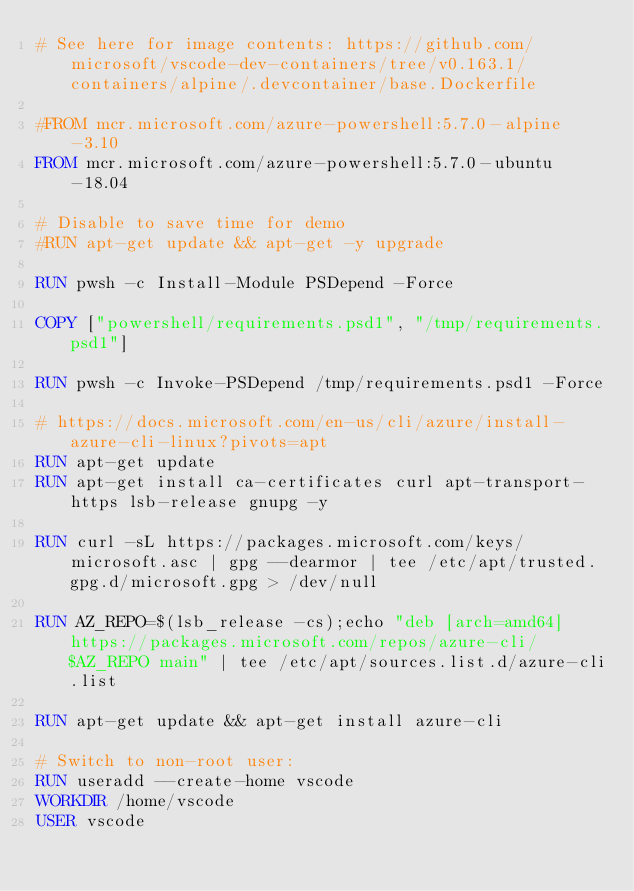<code> <loc_0><loc_0><loc_500><loc_500><_Dockerfile_># See here for image contents: https://github.com/microsoft/vscode-dev-containers/tree/v0.163.1/containers/alpine/.devcontainer/base.Dockerfile

#FROM mcr.microsoft.com/azure-powershell:5.7.0-alpine-3.10
FROM mcr.microsoft.com/azure-powershell:5.7.0-ubuntu-18.04

# Disable to save time for demo
#RUN apt-get update && apt-get -y upgrade

RUN pwsh -c Install-Module PSDepend -Force

COPY ["powershell/requirements.psd1", "/tmp/requirements.psd1"]

RUN pwsh -c Invoke-PSDepend /tmp/requirements.psd1 -Force

# https://docs.microsoft.com/en-us/cli/azure/install-azure-cli-linux?pivots=apt
RUN apt-get update
RUN apt-get install ca-certificates curl apt-transport-https lsb-release gnupg -y

RUN curl -sL https://packages.microsoft.com/keys/microsoft.asc | gpg --dearmor | tee /etc/apt/trusted.gpg.d/microsoft.gpg > /dev/null

RUN AZ_REPO=$(lsb_release -cs);echo "deb [arch=amd64] https://packages.microsoft.com/repos/azure-cli/ $AZ_REPO main" | tee /etc/apt/sources.list.d/azure-cli.list

RUN apt-get update && apt-get install azure-cli

# Switch to non-root user:
RUN useradd --create-home vscode
WORKDIR /home/vscode
USER vscode</code> 